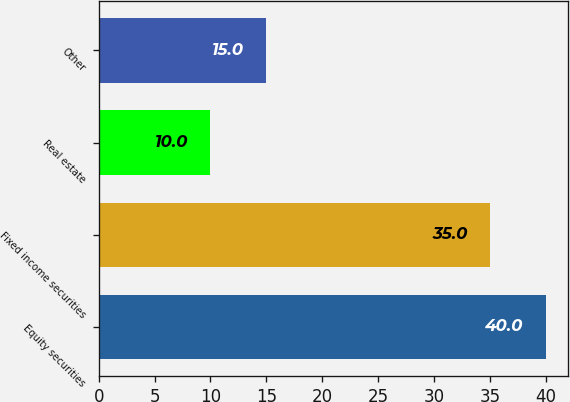Convert chart. <chart><loc_0><loc_0><loc_500><loc_500><bar_chart><fcel>Equity securities<fcel>Fixed income securities<fcel>Real estate<fcel>Other<nl><fcel>40<fcel>35<fcel>10<fcel>15<nl></chart> 